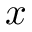<formula> <loc_0><loc_0><loc_500><loc_500>x</formula> 